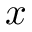<formula> <loc_0><loc_0><loc_500><loc_500>x</formula> 